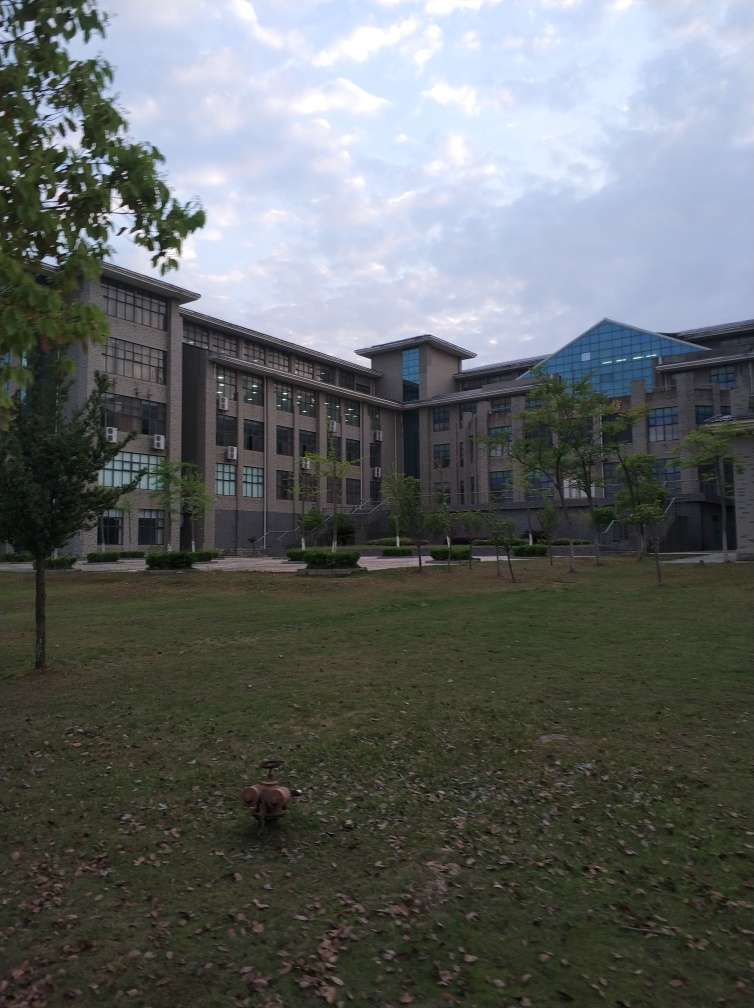What kind of use might this outdoor area have? This outdoor area, with its open grassy space and scattered trees, likely serves as a recreational or relaxation space. It could be used for various activities like casual walks, sitting and reading, or simply as a space for individuals to enjoy some fresh air amidst the urban environment of the buildings. 